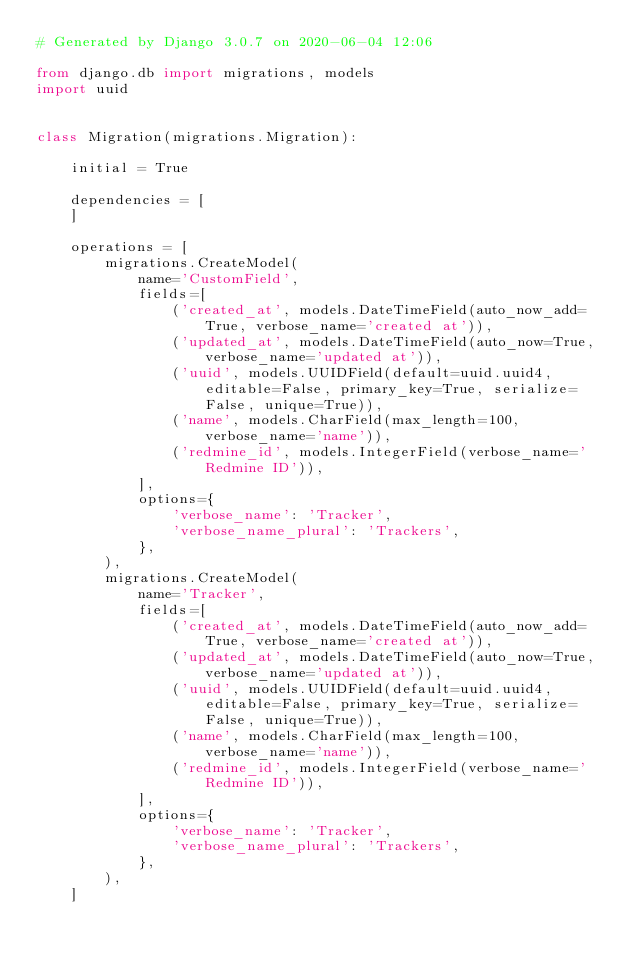Convert code to text. <code><loc_0><loc_0><loc_500><loc_500><_Python_># Generated by Django 3.0.7 on 2020-06-04 12:06

from django.db import migrations, models
import uuid


class Migration(migrations.Migration):

    initial = True

    dependencies = [
    ]

    operations = [
        migrations.CreateModel(
            name='CustomField',
            fields=[
                ('created_at', models.DateTimeField(auto_now_add=True, verbose_name='created at')),
                ('updated_at', models.DateTimeField(auto_now=True, verbose_name='updated at')),
                ('uuid', models.UUIDField(default=uuid.uuid4, editable=False, primary_key=True, serialize=False, unique=True)),
                ('name', models.CharField(max_length=100, verbose_name='name')),
                ('redmine_id', models.IntegerField(verbose_name='Redmine ID')),
            ],
            options={
                'verbose_name': 'Tracker',
                'verbose_name_plural': 'Trackers',
            },
        ),
        migrations.CreateModel(
            name='Tracker',
            fields=[
                ('created_at', models.DateTimeField(auto_now_add=True, verbose_name='created at')),
                ('updated_at', models.DateTimeField(auto_now=True, verbose_name='updated at')),
                ('uuid', models.UUIDField(default=uuid.uuid4, editable=False, primary_key=True, serialize=False, unique=True)),
                ('name', models.CharField(max_length=100, verbose_name='name')),
                ('redmine_id', models.IntegerField(verbose_name='Redmine ID')),
            ],
            options={
                'verbose_name': 'Tracker',
                'verbose_name_plural': 'Trackers',
            },
        ),
    ]
</code> 